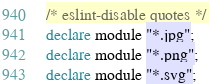<code> <loc_0><loc_0><loc_500><loc_500><_TypeScript_>/* eslint-disable quotes */
declare module "*.jpg";
declare module "*.png";
declare module "*.svg";
</code> 